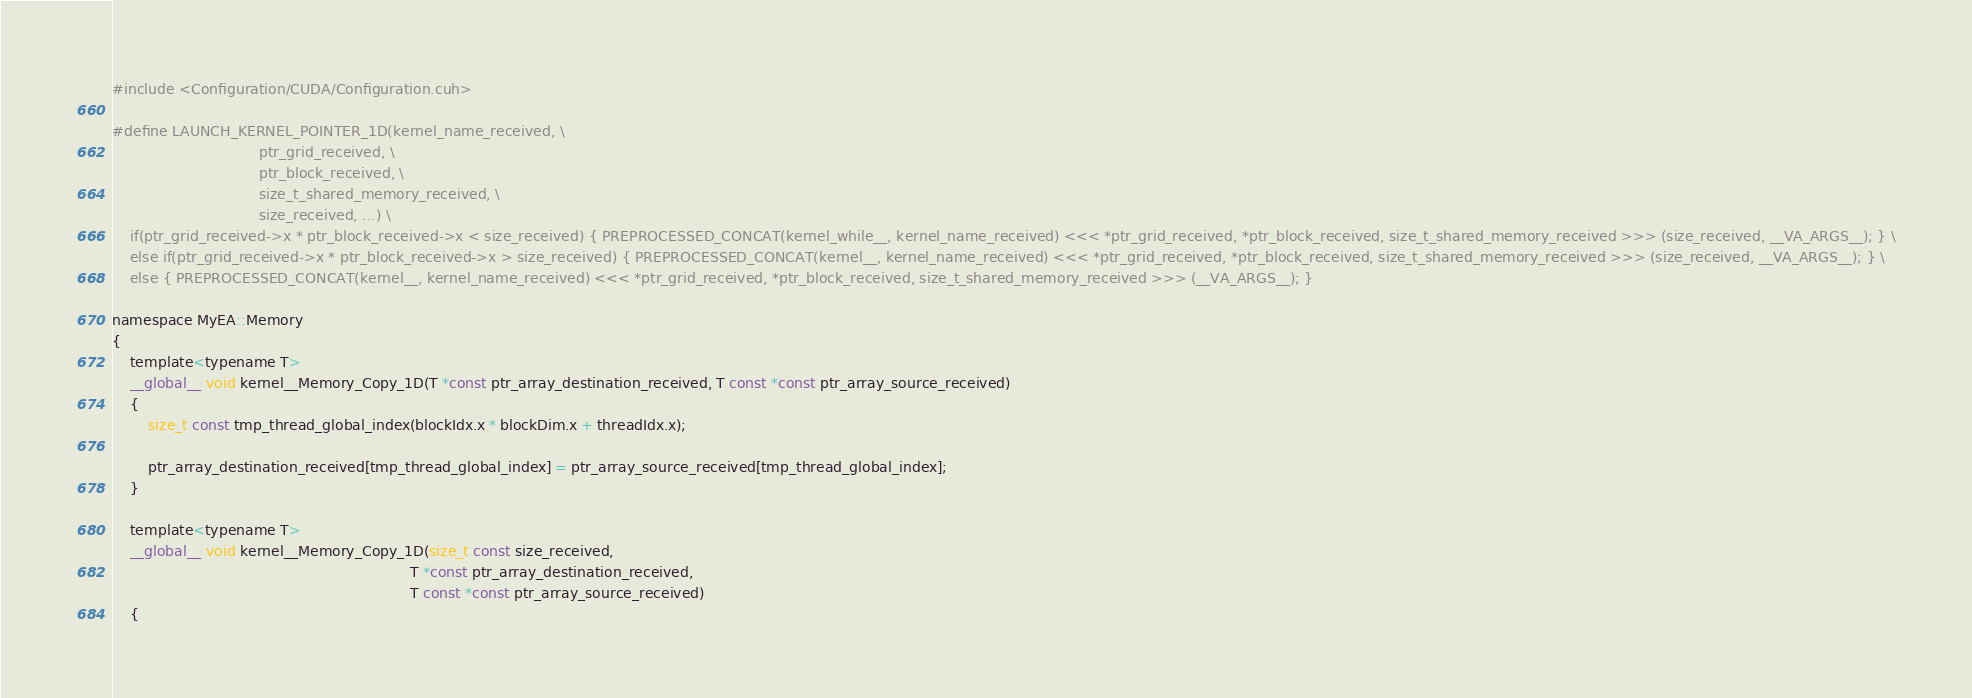<code> <loc_0><loc_0><loc_500><loc_500><_Cuda_>#include <Configuration/CUDA/Configuration.cuh>

#define LAUNCH_KERNEL_POINTER_1D(kernel_name_received, \
                                 ptr_grid_received, \
                                 ptr_block_received, \
                                 size_t_shared_memory_received, \
                                 size_received, ...) \
    if(ptr_grid_received->x * ptr_block_received->x < size_received) { PREPROCESSED_CONCAT(kernel_while__, kernel_name_received) <<< *ptr_grid_received, *ptr_block_received, size_t_shared_memory_received >>> (size_received, __VA_ARGS__); } \
    else if(ptr_grid_received->x * ptr_block_received->x > size_received) { PREPROCESSED_CONCAT(kernel__, kernel_name_received) <<< *ptr_grid_received, *ptr_block_received, size_t_shared_memory_received >>> (size_received, __VA_ARGS__); } \
    else { PREPROCESSED_CONCAT(kernel__, kernel_name_received) <<< *ptr_grid_received, *ptr_block_received, size_t_shared_memory_received >>> (__VA_ARGS__); }

namespace MyEA::Memory
{
    template<typename T>
    __global__ void kernel__Memory_Copy_1D(T *const ptr_array_destination_received, T const *const ptr_array_source_received)
    {
        size_t const tmp_thread_global_index(blockIdx.x * blockDim.x + threadIdx.x);

        ptr_array_destination_received[tmp_thread_global_index] = ptr_array_source_received[tmp_thread_global_index];
    }

    template<typename T>
    __global__ void kernel__Memory_Copy_1D(size_t const size_received,
                                                                   T *const ptr_array_destination_received,
                                                                   T const *const ptr_array_source_received)
    {</code> 